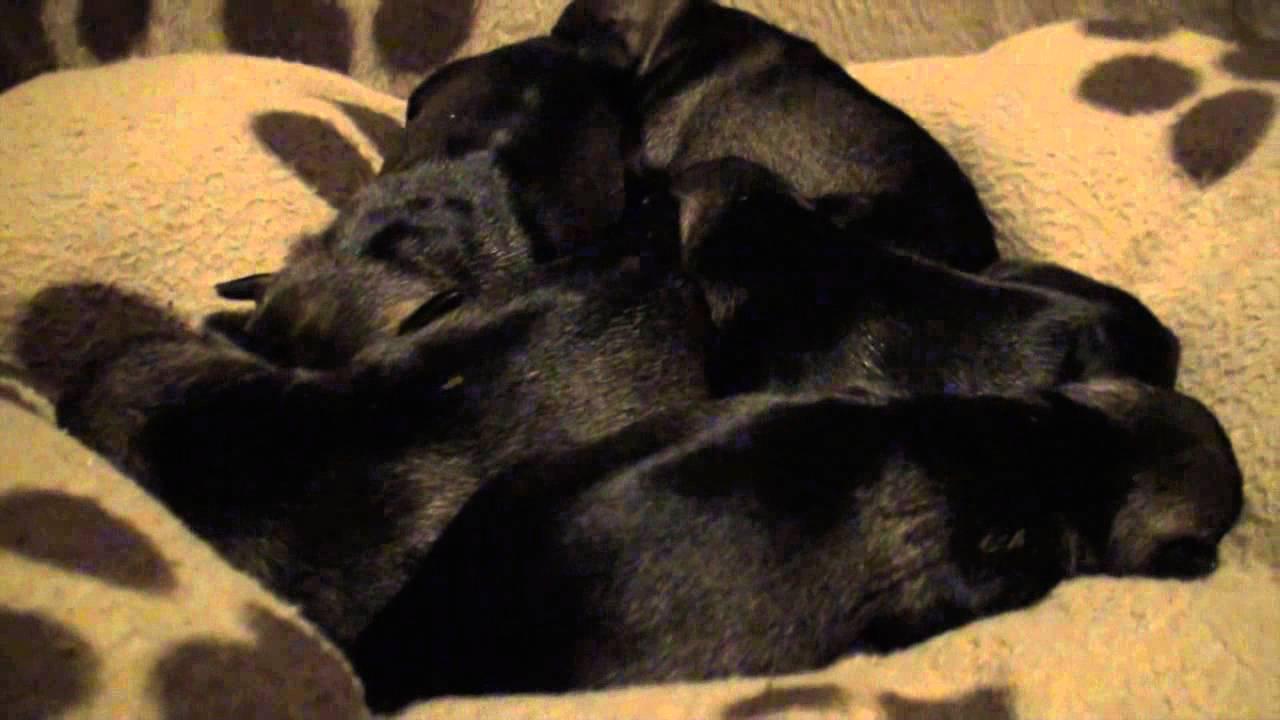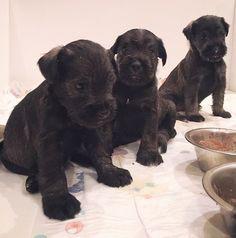The first image is the image on the left, the second image is the image on the right. Assess this claim about the two images: "there are puppies in a wooden box". Correct or not? Answer yes or no. No. The first image is the image on the left, the second image is the image on the right. For the images shown, is this caption "At least one puppy has white hair around it's mouth." true? Answer yes or no. No. 